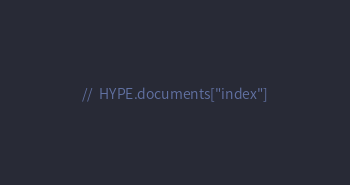<code> <loc_0><loc_0><loc_500><loc_500><_JavaScript_>//	HYPE.documents["index"]
</code> 